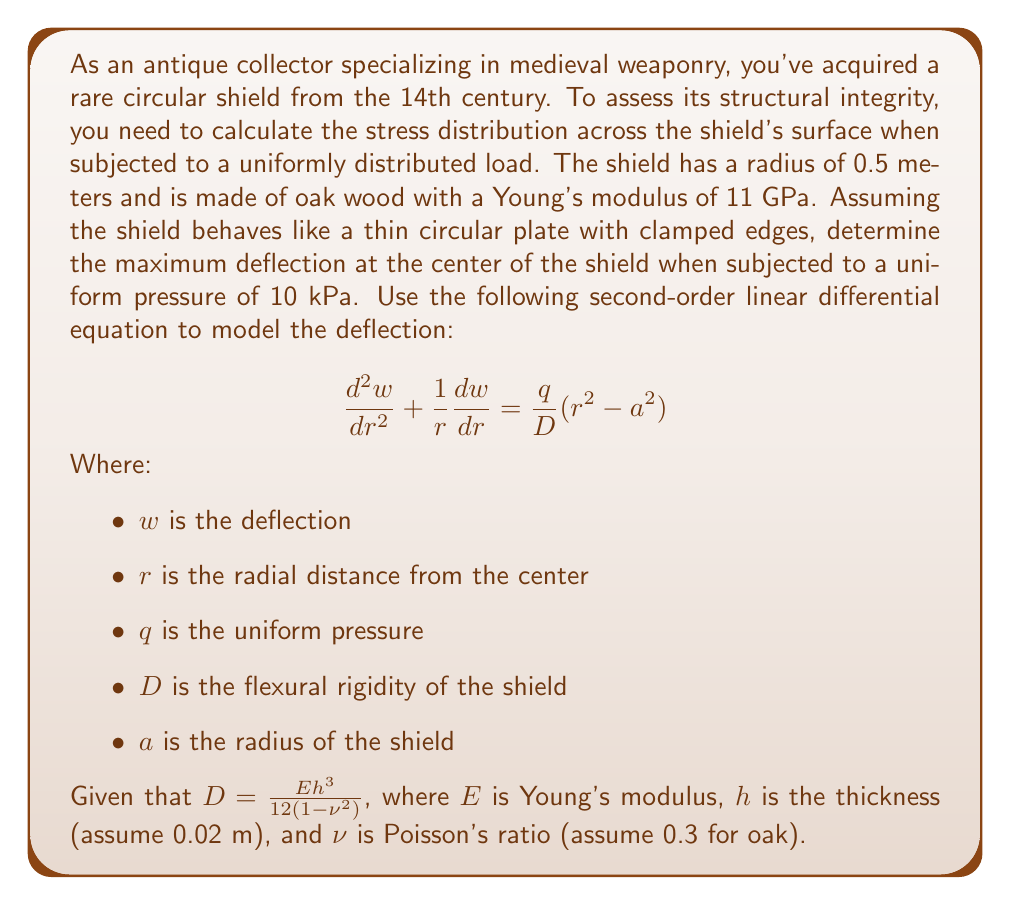Can you solve this math problem? To solve this problem, we'll follow these steps:

1) First, calculate the flexural rigidity $D$:
   $$D = \frac{Eh^3}{12(1-\nu^2)} = \frac{(11 \times 10^9)(0.02)^3}{12(1-0.3^2)} = 77.47 \text{ N⋅m}$$

2) The general solution to the differential equation is:
   $$w(r) = C_1r^2 + C_2r^2\ln(r) + C_3 + C_4\ln(r) + \frac{q}{64D}(a^2-r^2)^2$$

3) For a clamped circular plate, the boundary conditions are:
   At $r = a$: $w = 0$ and $\frac{dw}{dr} = 0$

4) Applying these boundary conditions, we can determine that $C_3 = \frac{qa^4}{64D}$ and $C_1 = C_2 = C_4 = 0$

5) Therefore, the deflection equation becomes:
   $$w(r) = \frac{q}{64D}(a^2-r^2)^2$$

6) The maximum deflection occurs at the center where $r = 0$:
   $$w_{max} = w(0) = \frac{q}{64D}a^4$$

7) Substituting the values:
   $q = 10,000 \text{ Pa}$
   $D = 77.47 \text{ N⋅m}$
   $a = 0.5 \text{ m}$

   $$w_{max} = \frac{10000}{64(77.47)}(0.5)^4 = 0.00126 \text{ m} = 1.26 \text{ mm}$$
Answer: The maximum deflection at the center of the shield is 1.26 mm. 